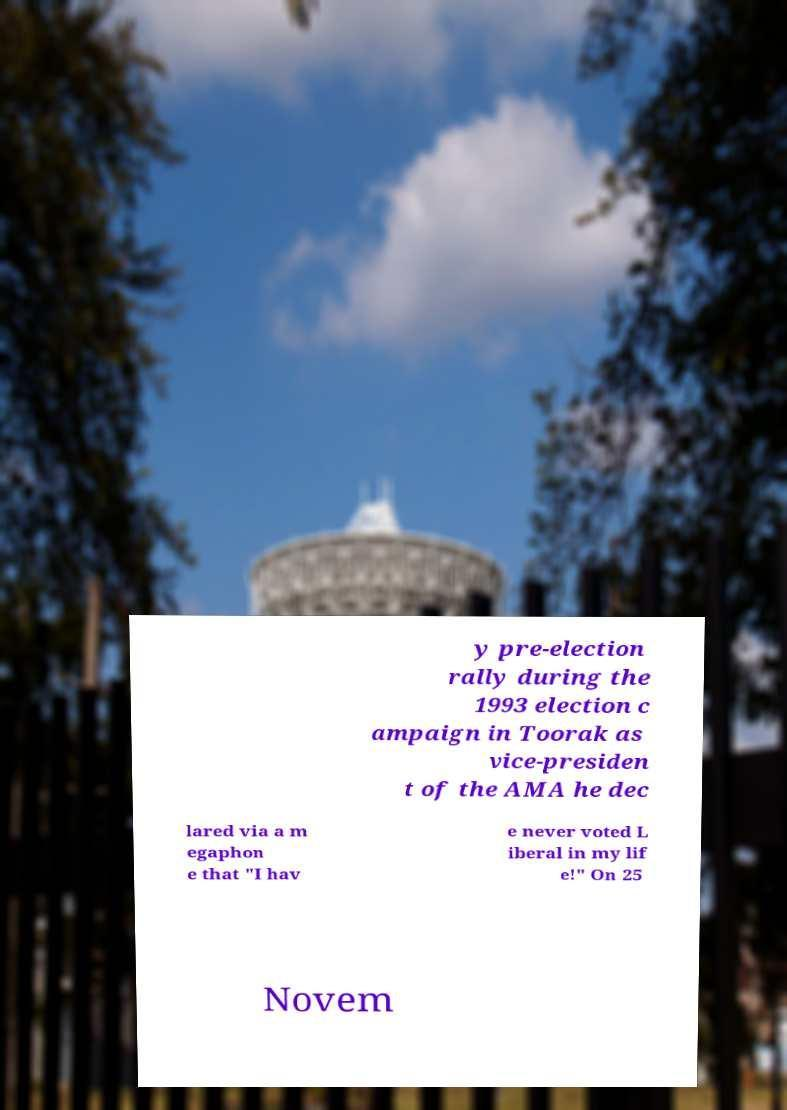Could you extract and type out the text from this image? y pre-election rally during the 1993 election c ampaign in Toorak as vice-presiden t of the AMA he dec lared via a m egaphon e that "I hav e never voted L iberal in my lif e!" On 25 Novem 